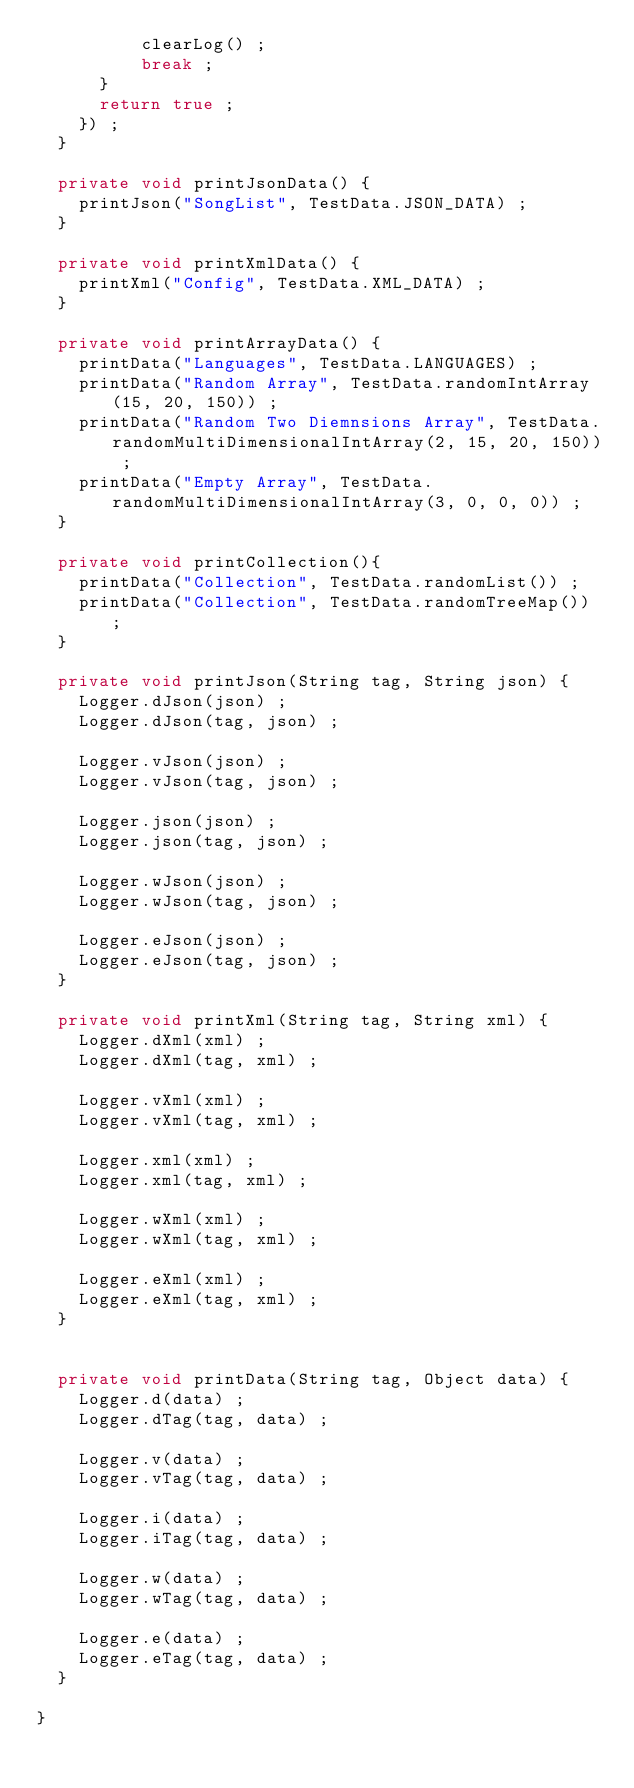<code> <loc_0><loc_0><loc_500><loc_500><_Java_>					clearLog() ;
					break ;
			}
			return true ;
		}) ;
	}
    
	private void printJsonData() {
		printJson("SongList", TestData.JSON_DATA) ;
	}
	
	private void printXmlData() {
		printXml("Config", TestData.XML_DATA) ;
	}
	
	private void printArrayData() {
		printData("Languages", TestData.LANGUAGES) ;
		printData("Random Array", TestData.randomIntArray(15, 20, 150)) ;
		printData("Random Two Diemnsions Array", TestData.randomMultiDimensionalIntArray(2, 15, 20, 150)) ;
		printData("Empty Array", TestData.randomMultiDimensionalIntArray(3, 0, 0, 0)) ;
	}
	
	private void printCollection(){
		printData("Collection", TestData.randomList()) ;
		printData("Collection", TestData.randomTreeMap()) ;
	}
	
	private void printJson(String tag, String json) {
		Logger.dJson(json) ;
		Logger.dJson(tag, json) ;
		
		Logger.vJson(json) ;
		Logger.vJson(tag, json) ;
		
		Logger.json(json) ;
		Logger.json(tag, json) ;

		Logger.wJson(json) ;
		Logger.wJson(tag, json) ;
		
		Logger.eJson(json) ;
		Logger.eJson(tag, json) ;
	}
	
	private void printXml(String tag, String xml) {
		Logger.dXml(xml) ;
		Logger.dXml(tag, xml) ;

		Logger.vXml(xml) ;
		Logger.vXml(tag, xml) ;

		Logger.xml(xml) ;
		Logger.xml(tag, xml) ;

		Logger.wXml(xml) ;
		Logger.wXml(tag, xml) ;

		Logger.eXml(xml) ;
		Logger.eXml(tag, xml) ;
	}
	
	
	private void printData(String tag, Object data) {
		Logger.d(data) ;
		Logger.dTag(tag, data) ;

		Logger.v(data) ;
		Logger.vTag(tag, data) ;

		Logger.i(data) ;
		Logger.iTag(tag, data) ;

		Logger.w(data) ;
		Logger.wTag(tag, data) ;

		Logger.e(data) ;
		Logger.eTag(tag, data) ;
	}
	
}
</code> 